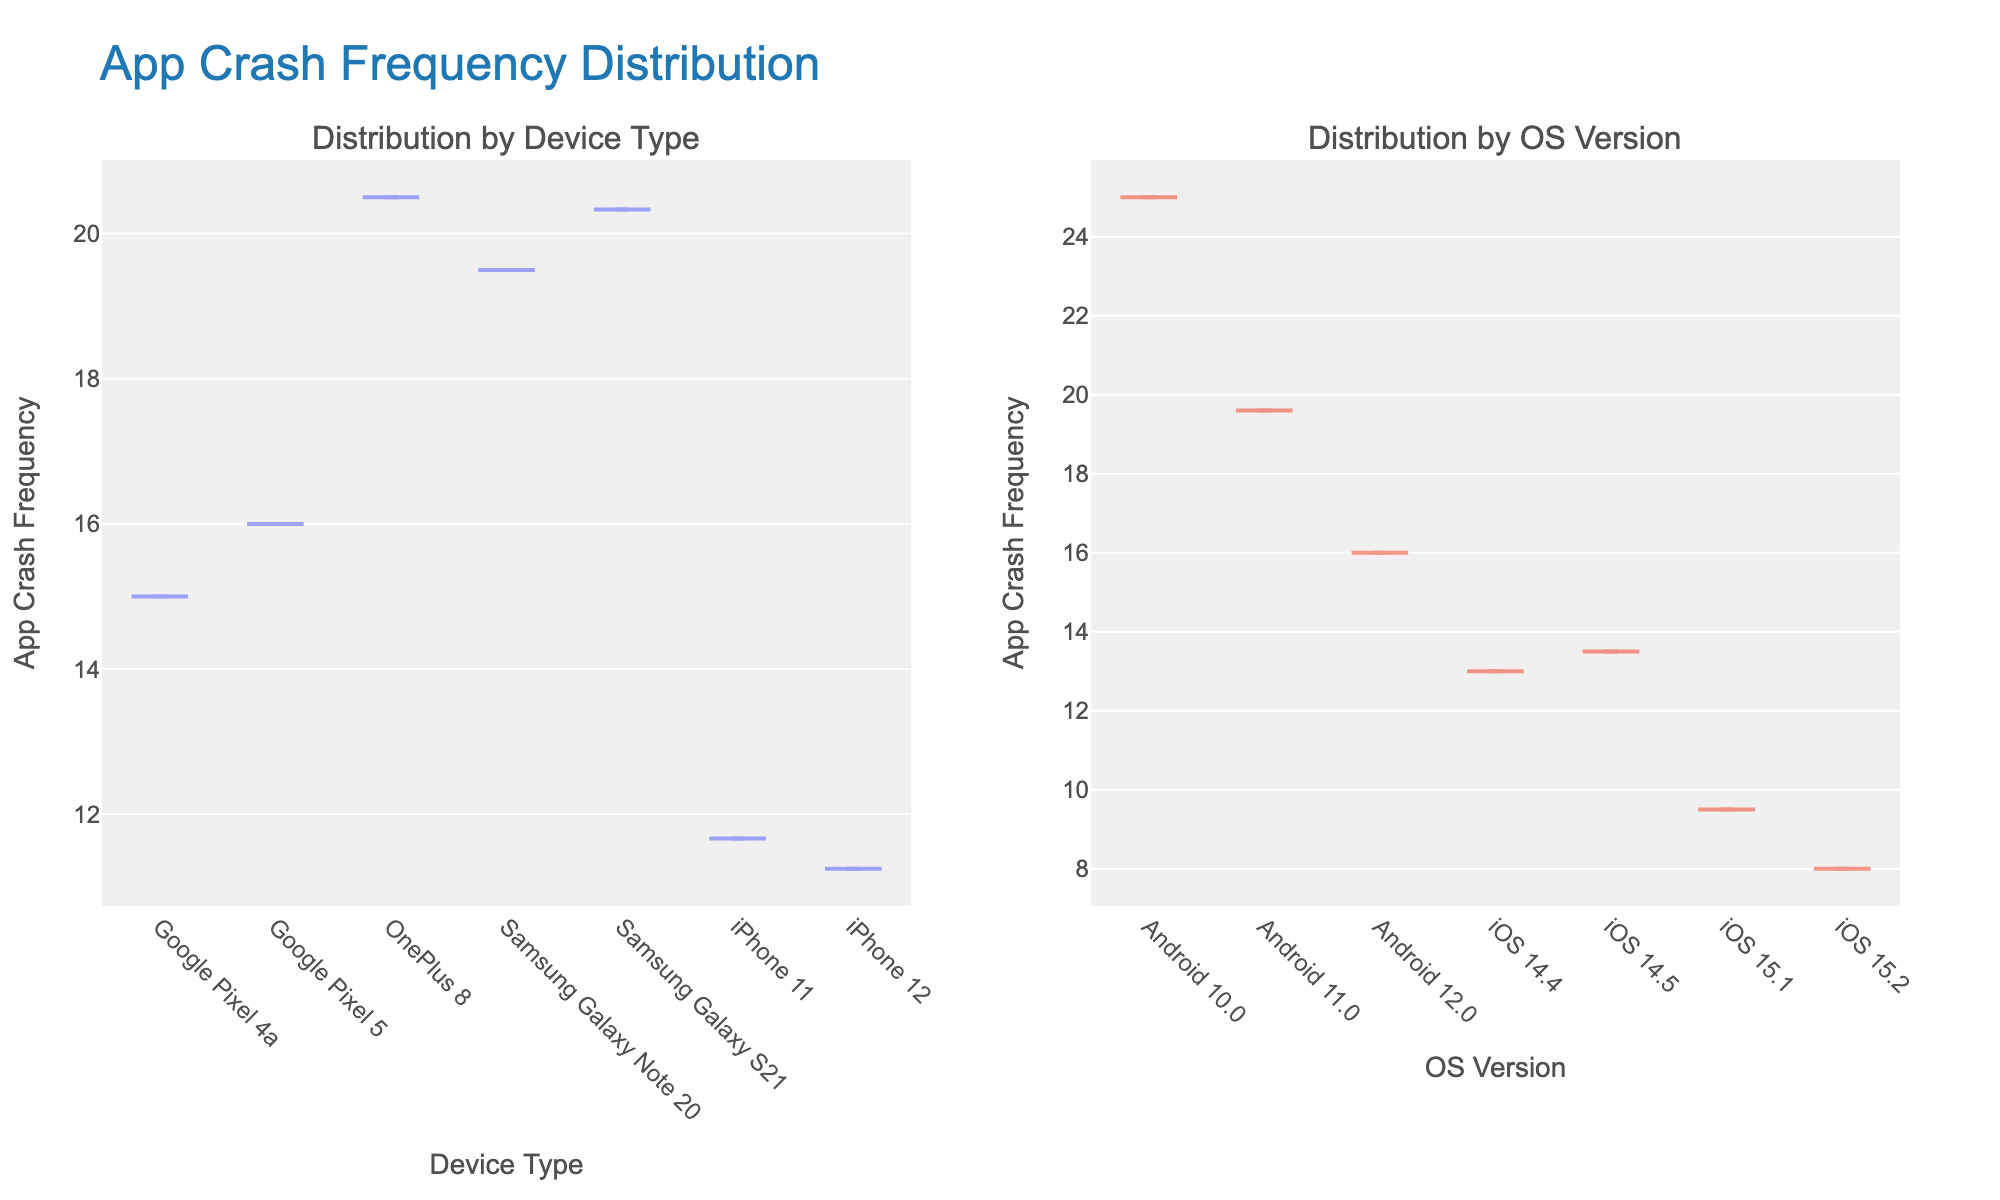what is the title of the figure? The title of the figure is displayed at the top of the plot. It reads 'App Crash Frequency Distribution'.
Answer: App Crash Frequency Distribution Which device type has the highest average app crash frequency? Look at the 'Distribution by Device Type' subplot. Identify the device type with the highest median value on the y-axis.
Answer: Samsung Galaxy S21 Which OS version has the lowest average app crash frequency? Refer to the 'Distribution by OS Version' subplot. The OS version with the lowest median value on the y-axis indicates the lowest average app crash frequency.
Answer: iOS 15.2 What is the average app crash frequency for iPhone 12? Find 'iPhone 12' on the x-axis of 'Distribution by Device Type' subplot. The corresponding y-value at the center of the box plot represents the average.
Answer: 11.25 Compare the average crash frequencies between iOS 14.5 and iOS 15.2. Which one is higher? Locate iOS 14.5 and iOS 15.2 on the x-axis of 'Distribution by OS Version' subplot. Compare their median values on the y-axis.
Answer: iOS 14.5 How does the app crash frequency distribution change among OS versions in the plot? Review the overall shapes and spreads of the violin plots in the 'Distribution by OS Version' subplot. Observe how they vary across different OS versions.
Answer: Varies Are app crashes more frequent on Android or iOS devices on average? Compare the overall median values of Android devices versus iOS devices in the 'Distribution by Device Type' subplot by noting the positions of the medians.
Answer: Android Which device type shows a wider distribution of app crash frequencies? Compare the width and length of the violin plots in the 'Distribution by Device Type' subplot to see which device type has a more spread out distribution.
Answer: Samsung Galaxy S21 Does Google Pixel 4a have a higher or lower average app crash frequency compared to OnePlus 8? Identify the median values for 'Google Pixel 4a' and 'OnePlus 8' in the 'Distribution by Device Type' subplot and compare them.
Answer: Lower What can you infer about app crashes for iPhone 12 as the iOS version increases? Look at 'iPhone 12' across different iOS versions in 'Distribution by OS Version'. Notice if the crash frequency tends to increase, decrease, or remain constant.
Answer: Decrease 